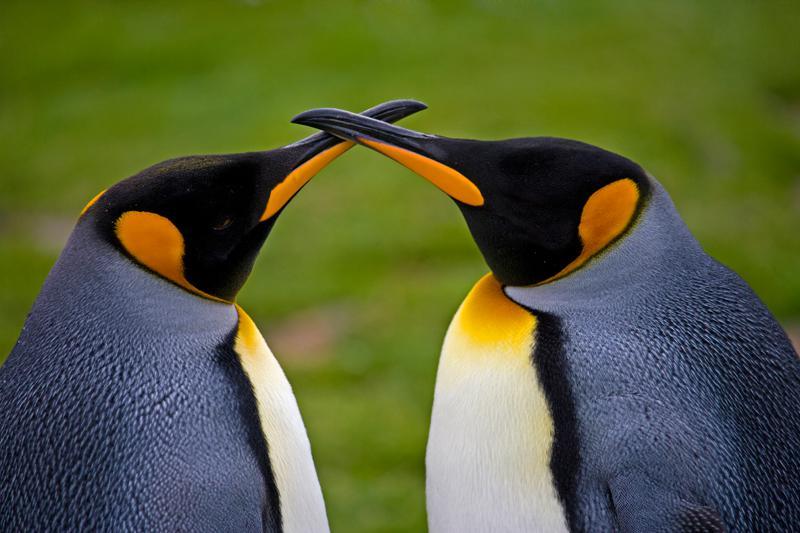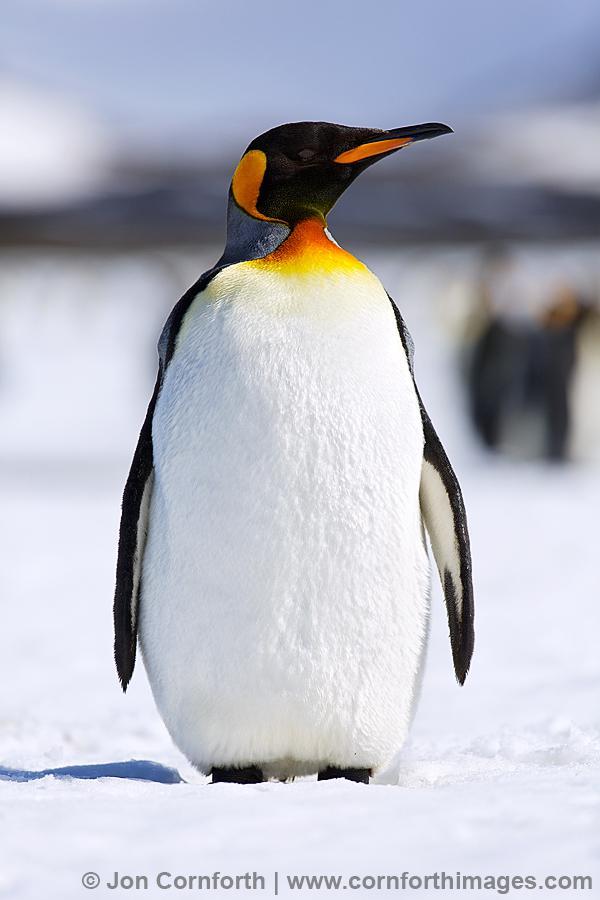The first image is the image on the left, the second image is the image on the right. Evaluate the accuracy of this statement regarding the images: "There are exactly three penguins.". Is it true? Answer yes or no. Yes. The first image is the image on the left, the second image is the image on the right. For the images shown, is this caption "2 penguins are facing each other with chests almost touching" true? Answer yes or no. Yes. 